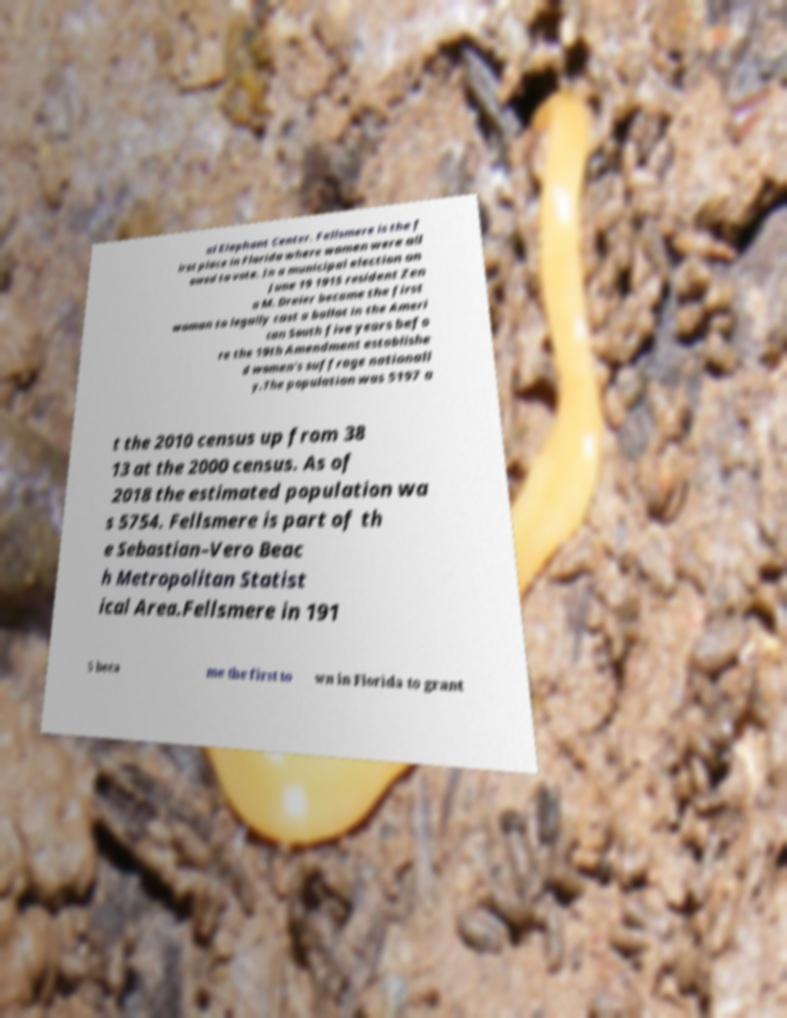For documentation purposes, I need the text within this image transcribed. Could you provide that? al Elephant Center. Fellsmere is the f irst place in Florida where women were all owed to vote. In a municipal election on June 19 1915 resident Zen a M. Dreier became the first woman to legally cast a ballot in the Ameri can South five years befo re the 19th Amendment establishe d women's suffrage nationall y.The population was 5197 a t the 2010 census up from 38 13 at the 2000 census. As of 2018 the estimated population wa s 5754. Fellsmere is part of th e Sebastian–Vero Beac h Metropolitan Statist ical Area.Fellsmere in 191 5 beca me the first to wn in Florida to grant 